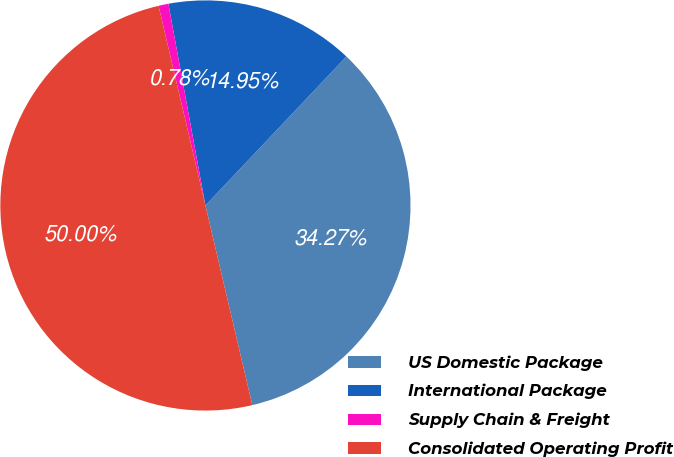Convert chart. <chart><loc_0><loc_0><loc_500><loc_500><pie_chart><fcel>US Domestic Package<fcel>International Package<fcel>Supply Chain & Freight<fcel>Consolidated Operating Profit<nl><fcel>34.27%<fcel>14.95%<fcel>0.78%<fcel>50.0%<nl></chart> 